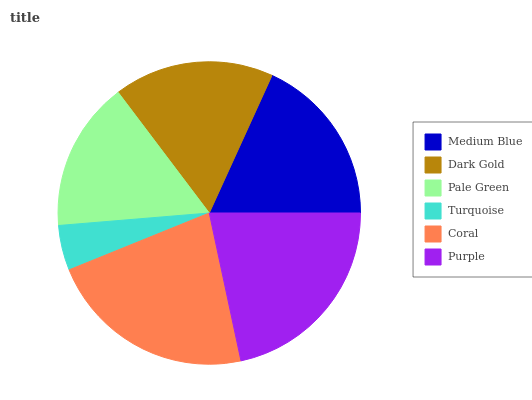Is Turquoise the minimum?
Answer yes or no. Yes. Is Coral the maximum?
Answer yes or no. Yes. Is Dark Gold the minimum?
Answer yes or no. No. Is Dark Gold the maximum?
Answer yes or no. No. Is Medium Blue greater than Dark Gold?
Answer yes or no. Yes. Is Dark Gold less than Medium Blue?
Answer yes or no. Yes. Is Dark Gold greater than Medium Blue?
Answer yes or no. No. Is Medium Blue less than Dark Gold?
Answer yes or no. No. Is Medium Blue the high median?
Answer yes or no. Yes. Is Dark Gold the low median?
Answer yes or no. Yes. Is Coral the high median?
Answer yes or no. No. Is Medium Blue the low median?
Answer yes or no. No. 